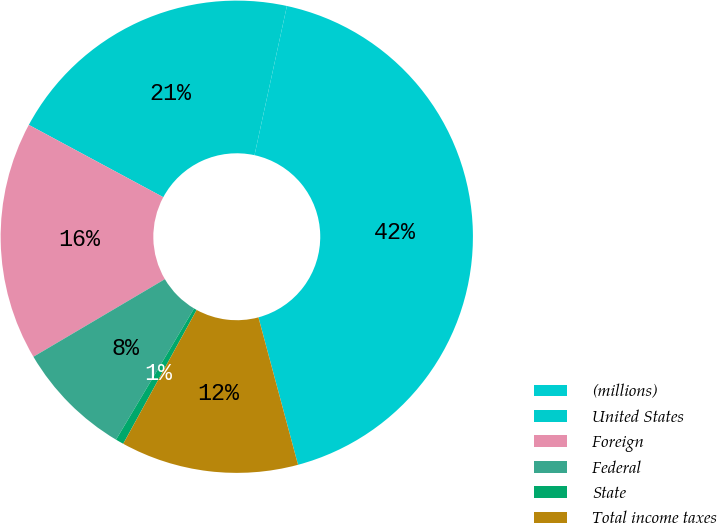Convert chart. <chart><loc_0><loc_0><loc_500><loc_500><pie_chart><fcel>(millions)<fcel>United States<fcel>Foreign<fcel>Federal<fcel>State<fcel>Total income taxes<nl><fcel>42.42%<fcel>20.55%<fcel>16.34%<fcel>7.97%<fcel>0.56%<fcel>12.16%<nl></chart> 